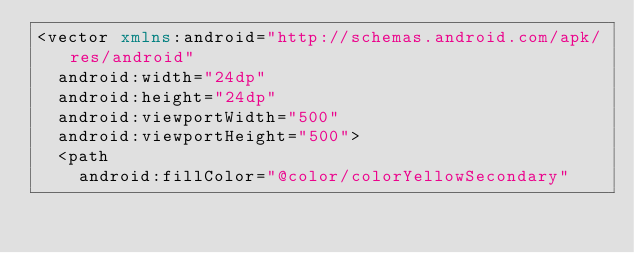<code> <loc_0><loc_0><loc_500><loc_500><_XML_><vector xmlns:android="http://schemas.android.com/apk/res/android"
  android:width="24dp"
  android:height="24dp"
  android:viewportWidth="500"
  android:viewportHeight="500">
  <path
    android:fillColor="@color/colorYellowSecondary"</code> 